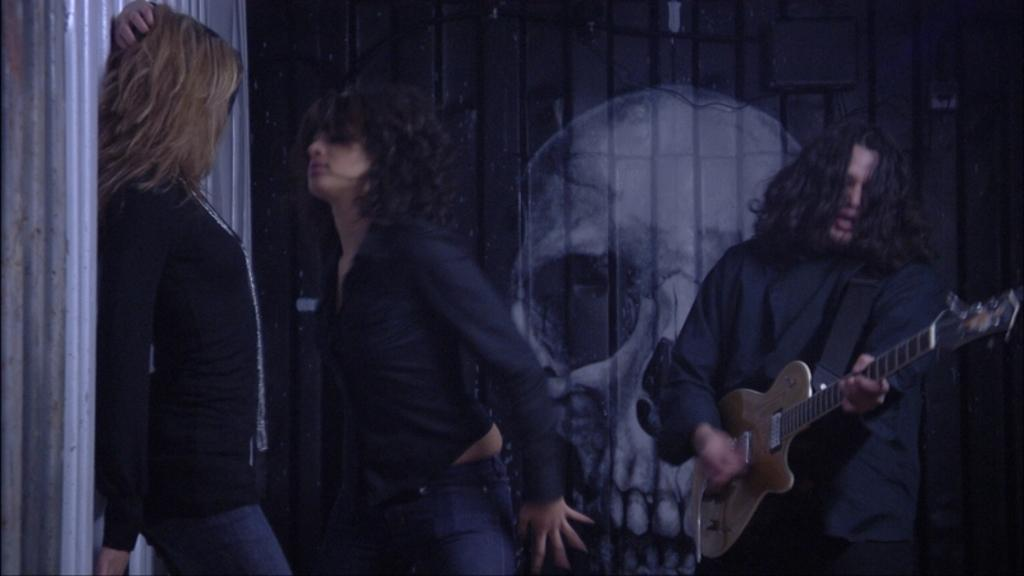How many people are in the image? There are people in the image, but the exact number is not specified. What is one person doing in the image? One person is holding a guitar in their hands. What type of bee can be seen buzzing around the guitar in the image? There is no bee present in the image; it only features people and a guitar. 